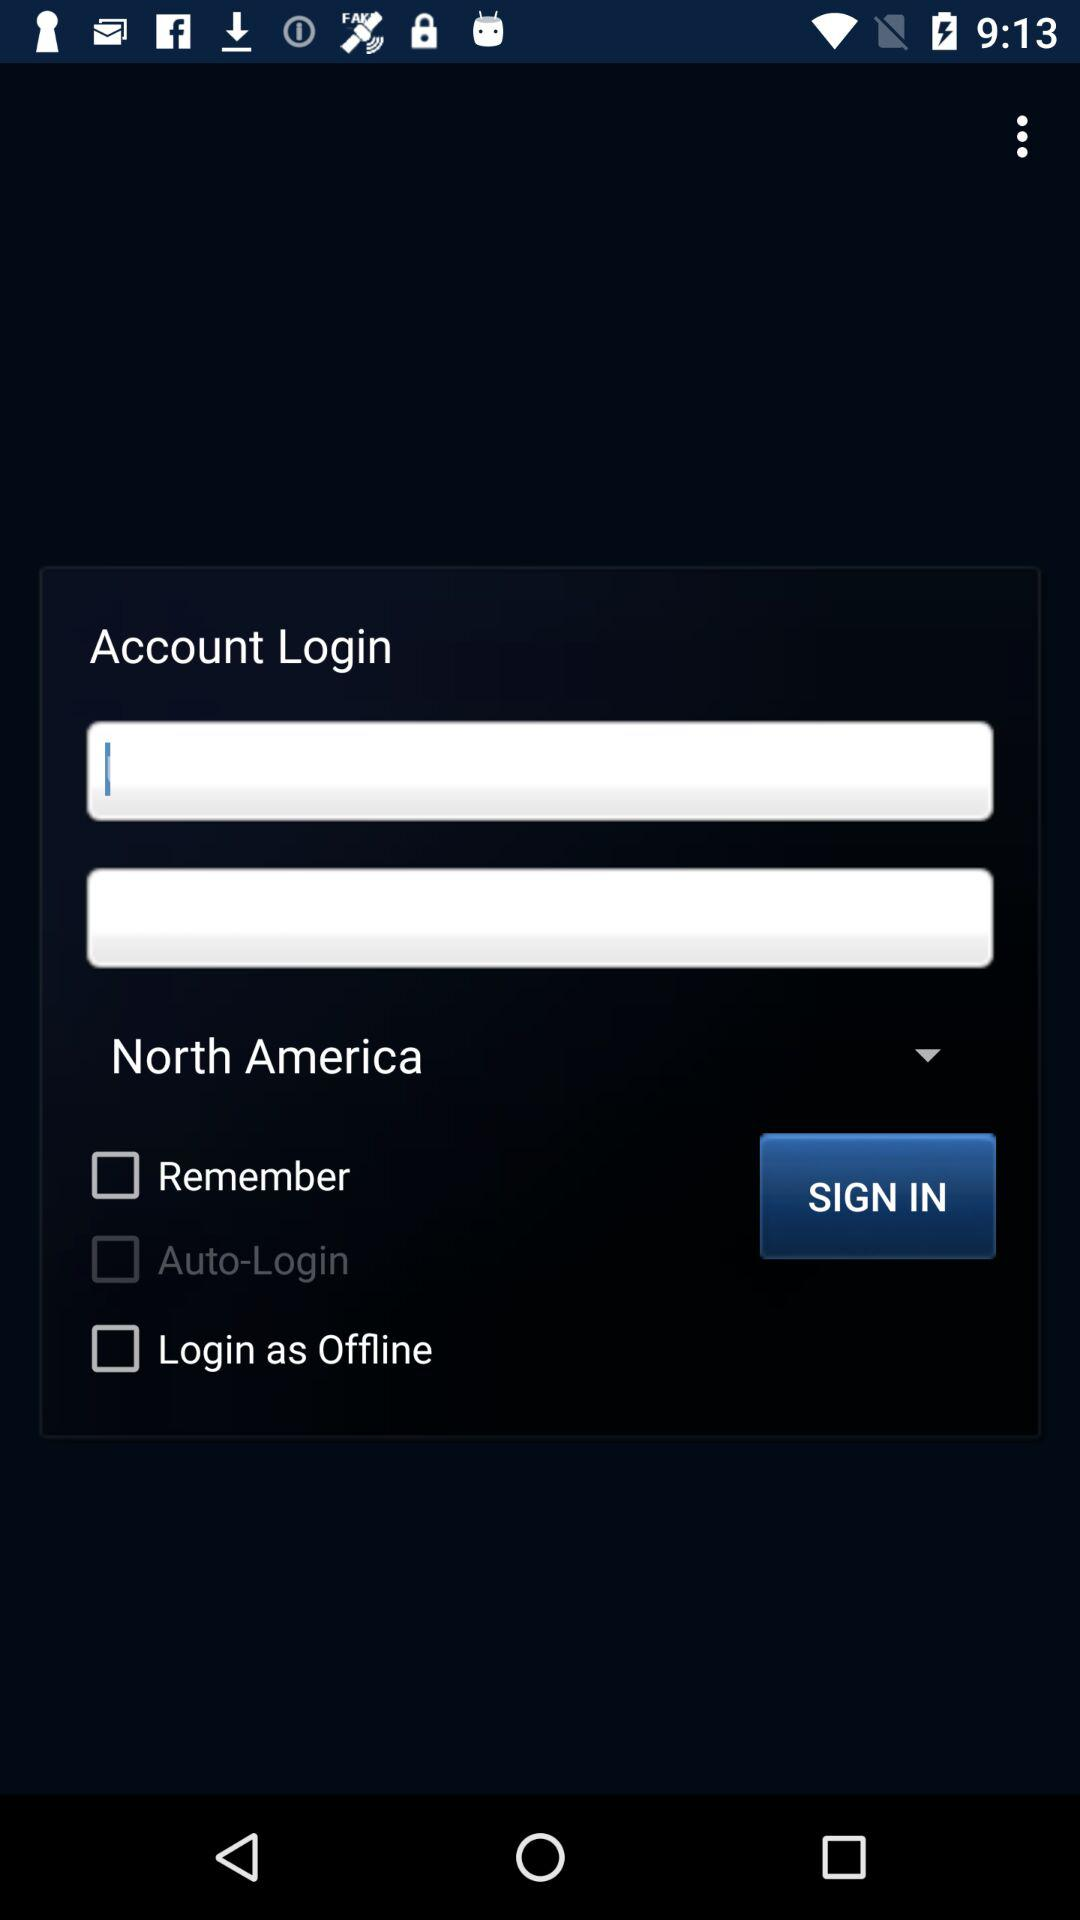How many options are there for how to login?
Answer the question using a single word or phrase. 3 